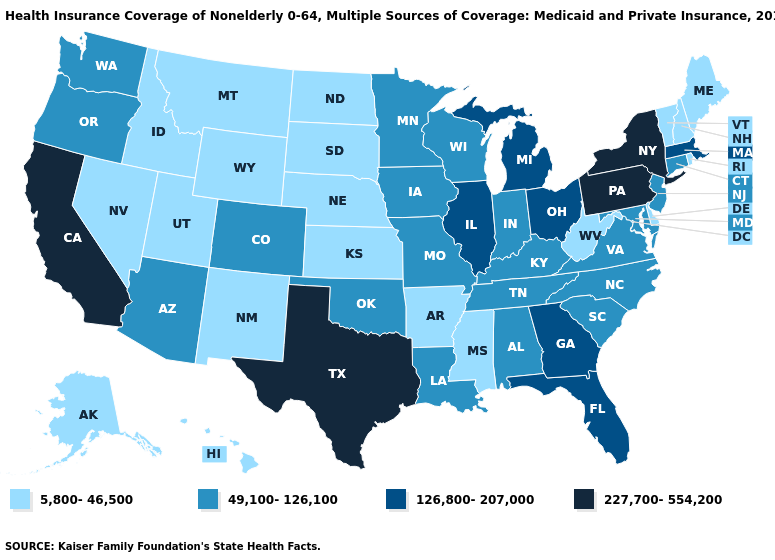Does the first symbol in the legend represent the smallest category?
Concise answer only. Yes. What is the highest value in the USA?
Be succinct. 227,700-554,200. Among the states that border Florida , does Georgia have the lowest value?
Keep it brief. No. What is the value of Wyoming?
Be succinct. 5,800-46,500. Name the states that have a value in the range 49,100-126,100?
Give a very brief answer. Alabama, Arizona, Colorado, Connecticut, Indiana, Iowa, Kentucky, Louisiana, Maryland, Minnesota, Missouri, New Jersey, North Carolina, Oklahoma, Oregon, South Carolina, Tennessee, Virginia, Washington, Wisconsin. What is the value of Arkansas?
Be succinct. 5,800-46,500. What is the value of Oklahoma?
Write a very short answer. 49,100-126,100. What is the value of Maine?
Concise answer only. 5,800-46,500. What is the value of Pennsylvania?
Answer briefly. 227,700-554,200. Is the legend a continuous bar?
Write a very short answer. No. Does New York have the same value as California?
Write a very short answer. Yes. Name the states that have a value in the range 227,700-554,200?
Write a very short answer. California, New York, Pennsylvania, Texas. Does Utah have the lowest value in the USA?
Short answer required. Yes. Name the states that have a value in the range 126,800-207,000?
Short answer required. Florida, Georgia, Illinois, Massachusetts, Michigan, Ohio. Name the states that have a value in the range 126,800-207,000?
Answer briefly. Florida, Georgia, Illinois, Massachusetts, Michigan, Ohio. 